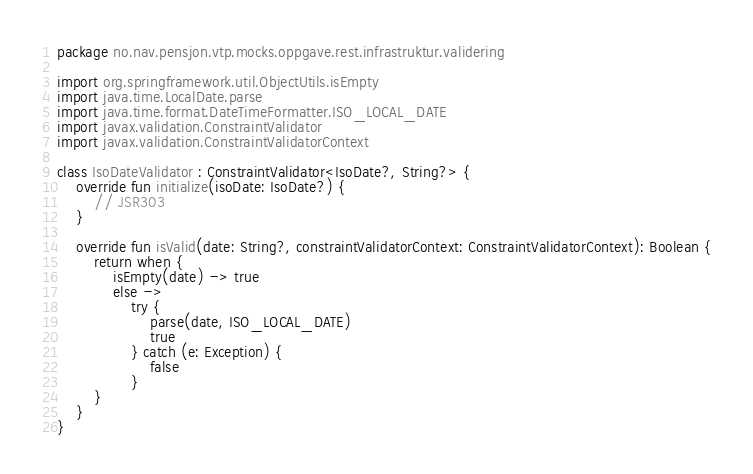<code> <loc_0><loc_0><loc_500><loc_500><_Kotlin_>package no.nav.pensjon.vtp.mocks.oppgave.rest.infrastruktur.validering

import org.springframework.util.ObjectUtils.isEmpty
import java.time.LocalDate.parse
import java.time.format.DateTimeFormatter.ISO_LOCAL_DATE
import javax.validation.ConstraintValidator
import javax.validation.ConstraintValidatorContext

class IsoDateValidator : ConstraintValidator<IsoDate?, String?> {
    override fun initialize(isoDate: IsoDate?) {
        // JSR303
    }

    override fun isValid(date: String?, constraintValidatorContext: ConstraintValidatorContext): Boolean {
        return when {
            isEmpty(date) -> true
            else ->
                try {
                    parse(date, ISO_LOCAL_DATE)
                    true
                } catch (e: Exception) {
                    false
                }
        }
    }
}
</code> 